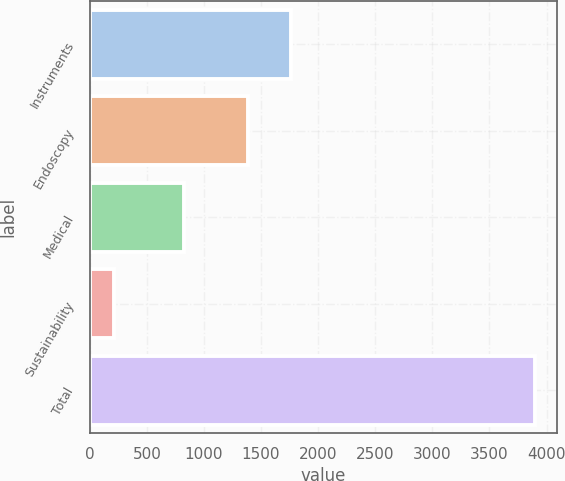Convert chart. <chart><loc_0><loc_0><loc_500><loc_500><bar_chart><fcel>Instruments<fcel>Endoscopy<fcel>Medical<fcel>Sustainability<fcel>Total<nl><fcel>1757.9<fcel>1390<fcel>823<fcel>216<fcel>3895<nl></chart> 